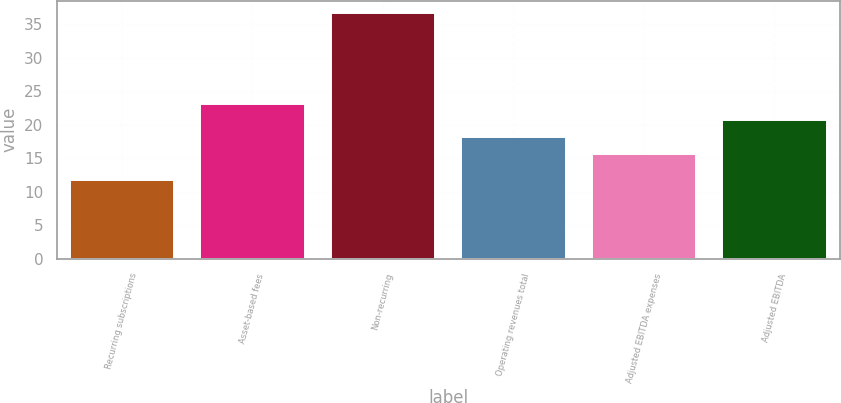Convert chart. <chart><loc_0><loc_0><loc_500><loc_500><bar_chart><fcel>Recurring subscriptions<fcel>Asset-based fees<fcel>Non-recurring<fcel>Operating revenues total<fcel>Adjusted EBITDA expenses<fcel>Adjusted EBITDA<nl><fcel>11.8<fcel>23.17<fcel>36.7<fcel>18.19<fcel>15.7<fcel>20.68<nl></chart> 